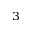<formula> <loc_0><loc_0><loc_500><loc_500>_ { 3 }</formula> 